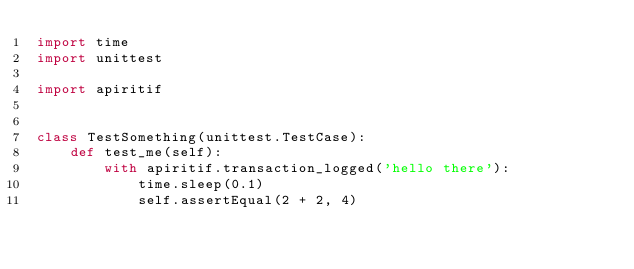Convert code to text. <code><loc_0><loc_0><loc_500><loc_500><_Python_>import time
import unittest

import apiritif


class TestSomething(unittest.TestCase):
    def test_me(self):
        with apiritif.transaction_logged('hello there'):
            time.sleep(0.1)
            self.assertEqual(2 + 2, 4)
</code> 